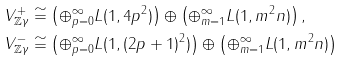<formula> <loc_0><loc_0><loc_500><loc_500>V _ { { \mathbb { Z } } \gamma } ^ { + } & \cong \left ( \oplus _ { p = 0 } ^ { \infty } L ( 1 , 4 p ^ { 2 } ) \right ) \oplus \left ( \oplus _ { m = 1 } ^ { \infty } L ( 1 , m ^ { 2 } n ) \right ) , \\ V _ { { \mathbb { Z } } \gamma } ^ { - } & \cong \left ( \oplus _ { p = 0 } ^ { \infty } L ( 1 , ( 2 p + 1 ) ^ { 2 } ) \right ) \oplus \left ( \oplus _ { m = 1 } ^ { \infty } L ( 1 , m ^ { 2 } n ) \right )</formula> 